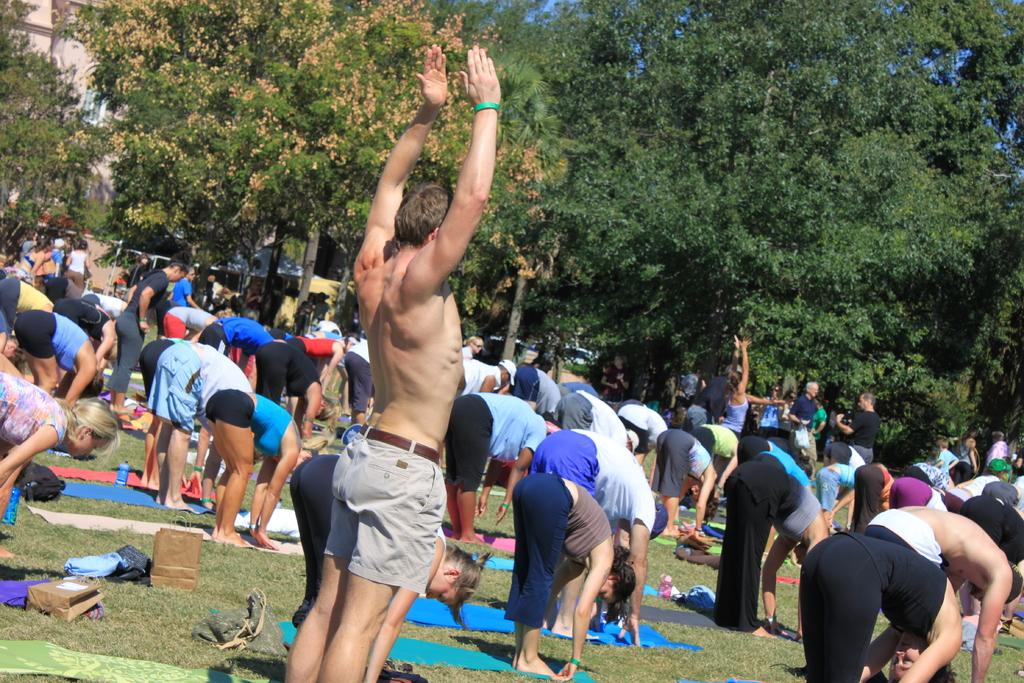What are the people in the image doing? The people in the image are doing yoga. Where are the people doing yoga? The people are on the grass. What can be seen in the background of the image? There are trees and buildings in the image. What numerical value is being sorted by the people in the image? There is no indication of any sorting or numerical values in the image; it features people doing yoga on the grass with trees and buildings in the background. 